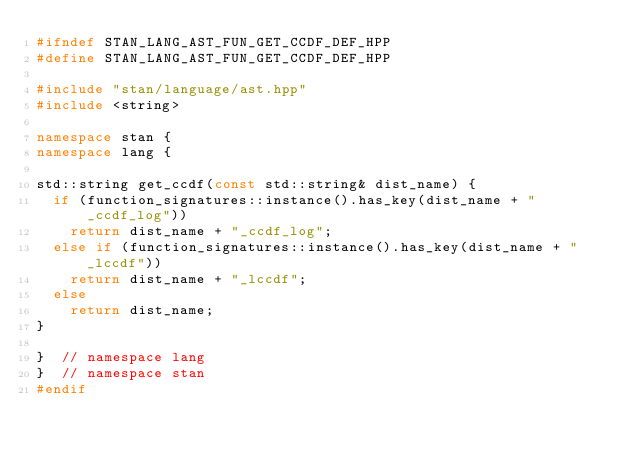Convert code to text. <code><loc_0><loc_0><loc_500><loc_500><_C++_>#ifndef STAN_LANG_AST_FUN_GET_CCDF_DEF_HPP
#define STAN_LANG_AST_FUN_GET_CCDF_DEF_HPP

#include "stan/language/ast.hpp"
#include <string>

namespace stan {
namespace lang {

std::string get_ccdf(const std::string& dist_name) {
  if (function_signatures::instance().has_key(dist_name + "_ccdf_log"))
    return dist_name + "_ccdf_log";
  else if (function_signatures::instance().has_key(dist_name + "_lccdf"))
    return dist_name + "_lccdf";
  else
    return dist_name;
}

}  // namespace lang
}  // namespace stan
#endif
</code> 